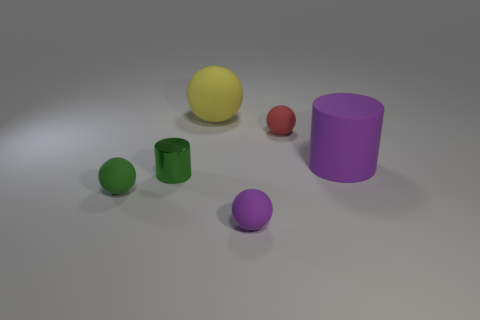Subtract all small purple spheres. How many spheres are left? 3 Subtract all green balls. How many balls are left? 3 Add 4 tiny red matte spheres. How many objects exist? 10 Subtract all red spheres. How many purple cylinders are left? 1 Subtract all cylinders. How many objects are left? 4 Subtract 1 cylinders. How many cylinders are left? 1 Subtract all blue cylinders. Subtract all brown spheres. How many cylinders are left? 2 Subtract all large brown rubber objects. Subtract all matte cylinders. How many objects are left? 5 Add 6 green cylinders. How many green cylinders are left? 7 Add 5 yellow spheres. How many yellow spheres exist? 6 